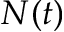Convert formula to latex. <formula><loc_0><loc_0><loc_500><loc_500>N ( t )</formula> 